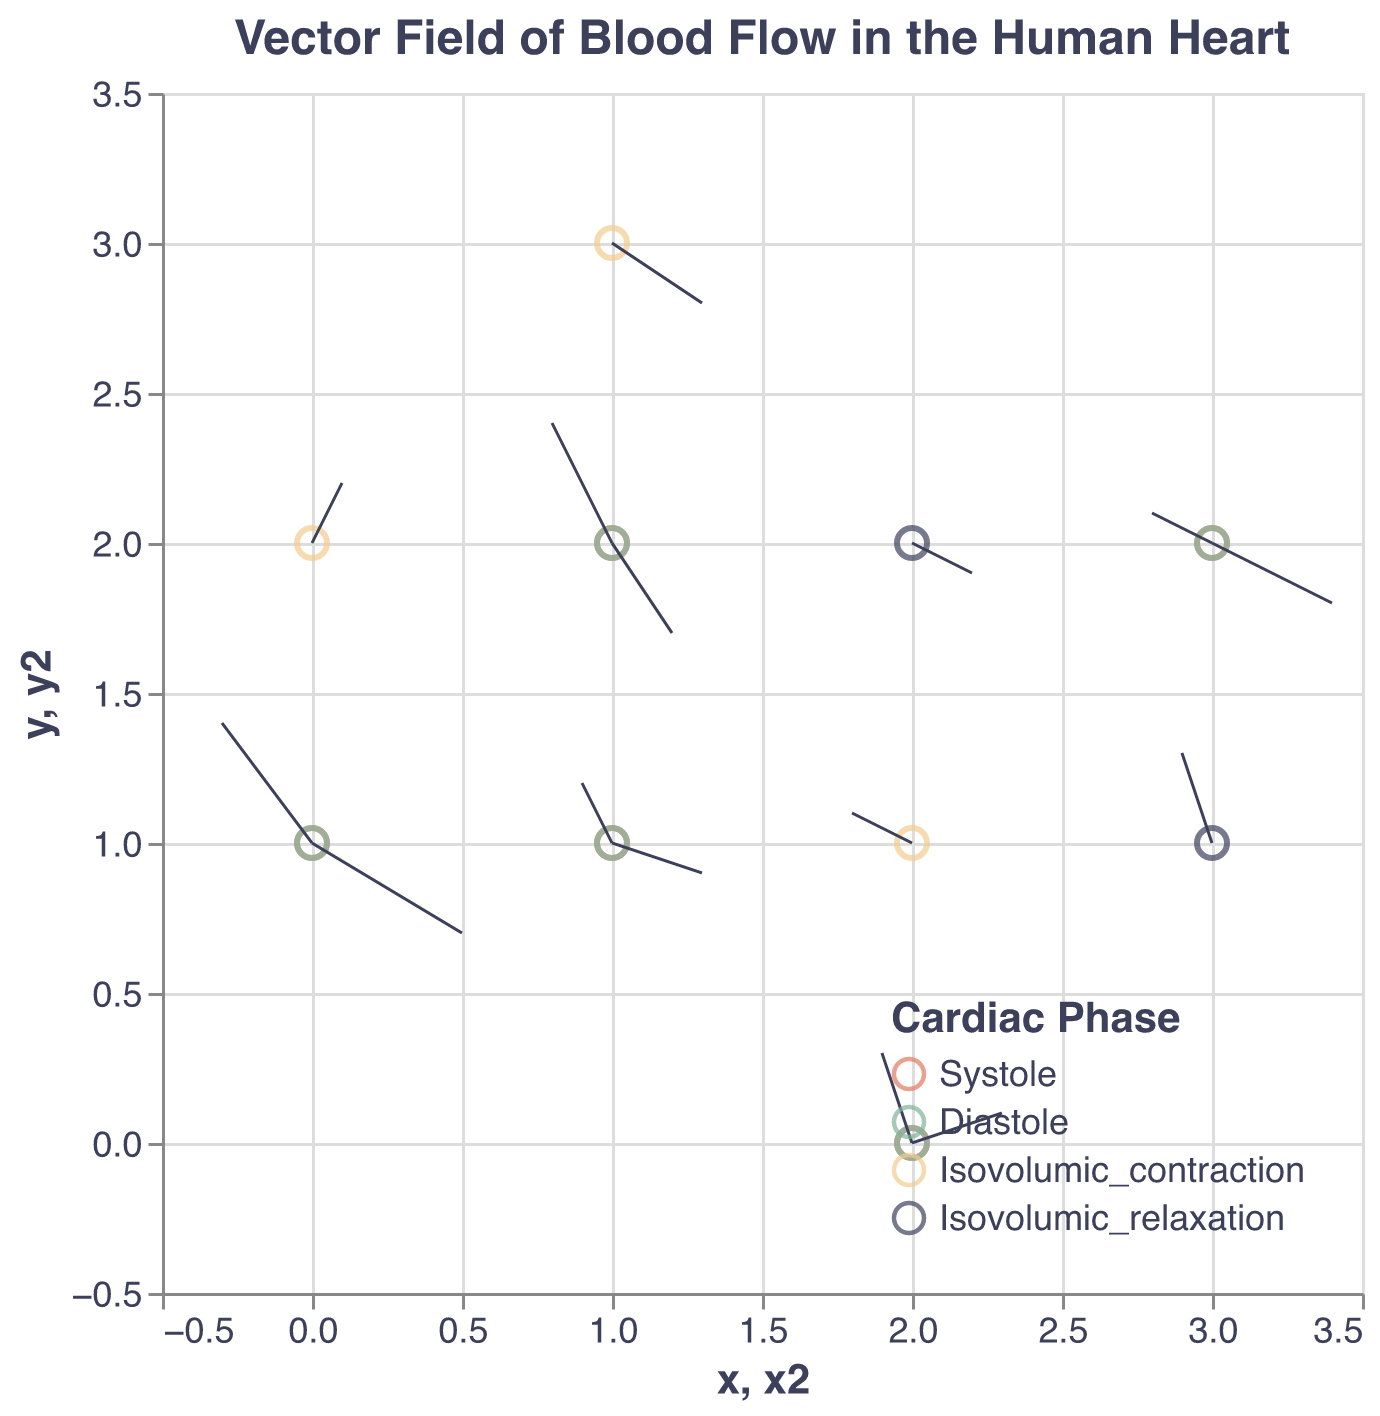What is the title of the figure? The title of the figure is usually displayed at the top, and the given code specifies it as "Vector Field of Blood Flow in the Human Heart".
Answer: Vector Field of Blood Flow in the Human Heart How many unique cardiac phases are represented in the figure? By looking at the legend in the figure, we can see four unique labels for the cardiac phases: Systole, Diastole, Isovolumic_contraction, Isovolumic_relaxation.
Answer: Four Which cardiac phase uses the color associated with #81B29A? The legend maps colors to cardiac phases. The color #81B29A (which is a green shade) corresponds to Diastole.
Answer: Diastole Which data point in the systole phase has the largest magnitude vector? The magnitude of a vector can be calculated using sqrt(u^2 + v^2 + w^2) for each vector in the systole phase. Evaluate and compare the magnitudes of all systole vectors, then identify the highest one.
Answer: (0, 1, 2) What are the coordinates of the point with the largest vector in the diastole phase? Similar to the previous question, calculate the magnitudes of vectors in the diastole phase and identify the point with the largest one.
Answer: (1, 1, 2) Which cardiac phase exhibits the most diverse range in vector directions? To determine this, compare the ranges of the u, v, and w components for each phase. The phase with the widest variation in these values will be the most diverse.
Answer: Systole Comparing the systole and diastole phases, which has vectors pointing more positively in the x-direction? Summarize the u components for vectors in both phases and compare their values. The phase with the larger sum of positive u values points more positively in the x-direction.
Answer: Systole Which cardiac phase has the data point with the highest z-coordinate, and what is this coordinate value? Review the z-coordinates across all phases and identify the highest value. Note that this is 3, and it belongs to both Systole and Diastole phases. So, we further identify the specific data points.
Answer: Systole and Diastole, z = 3 In the isovolumic_relaxation phase, which vector has the smallest v component? Examine the vectors within the isovolumic_relaxation phase and compare their v components to find the smallest one.
Answer: (2, 2, 1) 